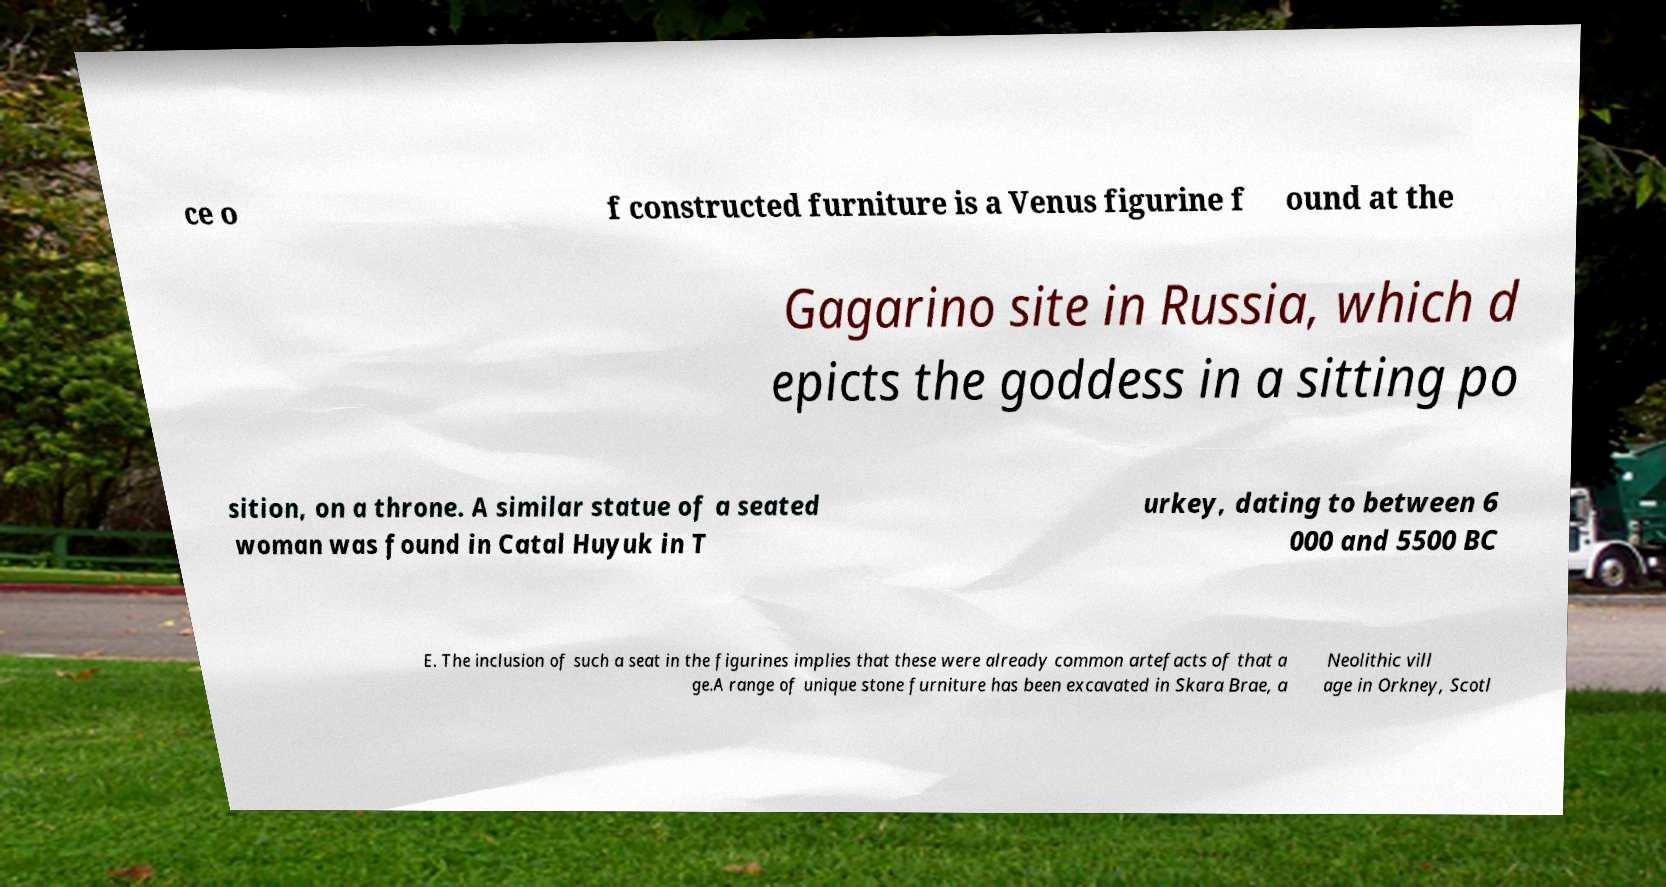Please read and relay the text visible in this image. What does it say? ce o f constructed furniture is a Venus figurine f ound at the Gagarino site in Russia, which d epicts the goddess in a sitting po sition, on a throne. A similar statue of a seated woman was found in Catal Huyuk in T urkey, dating to between 6 000 and 5500 BC E. The inclusion of such a seat in the figurines implies that these were already common artefacts of that a ge.A range of unique stone furniture has been excavated in Skara Brae, a Neolithic vill age in Orkney, Scotl 